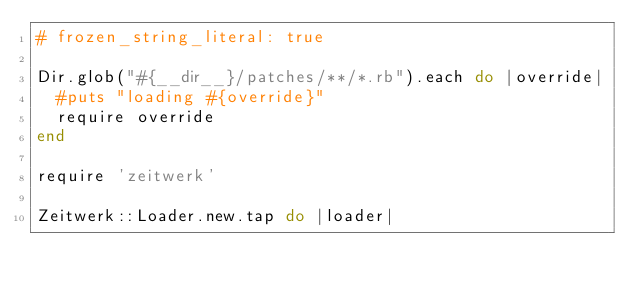<code> <loc_0><loc_0><loc_500><loc_500><_Ruby_># frozen_string_literal: true

Dir.glob("#{__dir__}/patches/**/*.rb").each do |override|
  #puts "loading #{override}"
  require override
end

require 'zeitwerk'

Zeitwerk::Loader.new.tap do |loader|</code> 